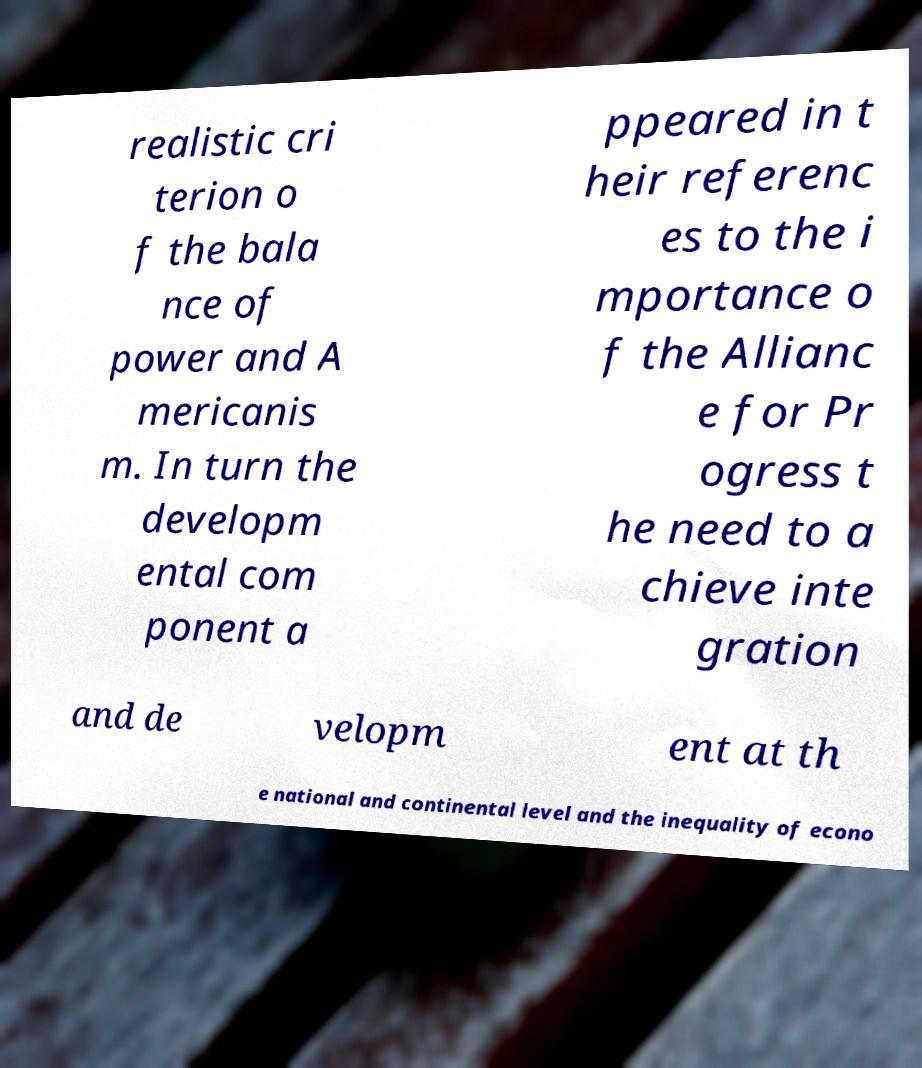Please read and relay the text visible in this image. What does it say? realistic cri terion o f the bala nce of power and A mericanis m. In turn the developm ental com ponent a ppeared in t heir referenc es to the i mportance o f the Allianc e for Pr ogress t he need to a chieve inte gration and de velopm ent at th e national and continental level and the inequality of econo 